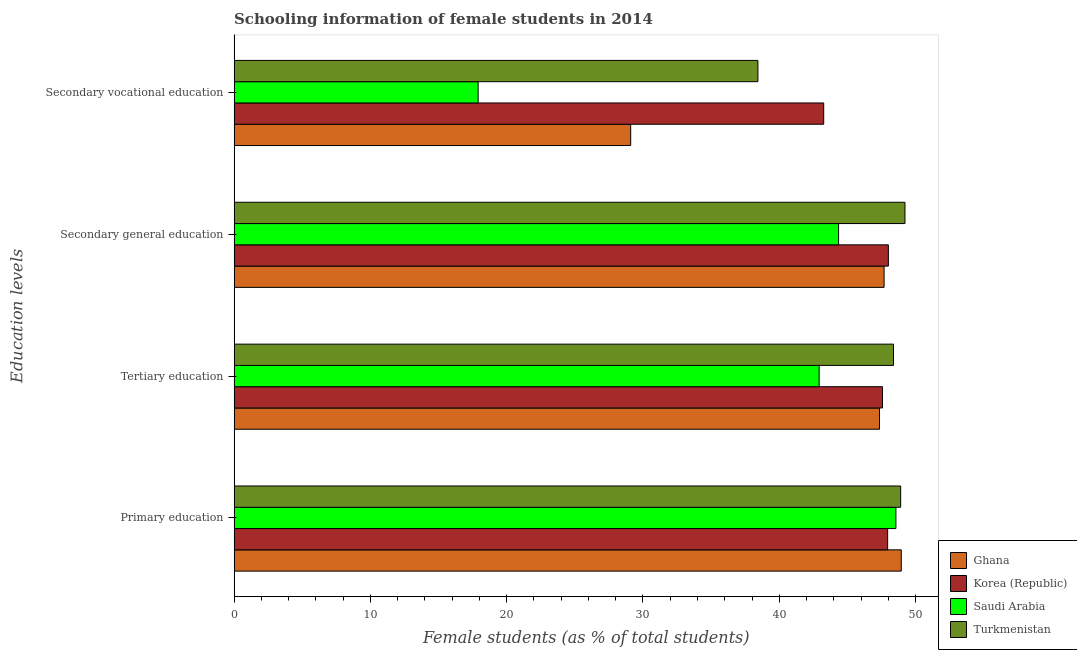Are the number of bars per tick equal to the number of legend labels?
Ensure brevity in your answer.  Yes. Are the number of bars on each tick of the Y-axis equal?
Provide a succinct answer. Yes. How many bars are there on the 3rd tick from the top?
Make the answer very short. 4. How many bars are there on the 2nd tick from the bottom?
Provide a succinct answer. 4. What is the label of the 3rd group of bars from the top?
Offer a terse response. Tertiary education. What is the percentage of female students in secondary education in Korea (Republic)?
Offer a very short reply. 48.01. Across all countries, what is the maximum percentage of female students in primary education?
Keep it short and to the point. 48.95. Across all countries, what is the minimum percentage of female students in secondary vocational education?
Your answer should be very brief. 17.91. In which country was the percentage of female students in tertiary education maximum?
Make the answer very short. Turkmenistan. In which country was the percentage of female students in secondary vocational education minimum?
Your answer should be compact. Saudi Arabia. What is the total percentage of female students in tertiary education in the graph?
Ensure brevity in your answer.  186.24. What is the difference between the percentage of female students in tertiary education in Turkmenistan and that in Saudi Arabia?
Give a very brief answer. 5.46. What is the difference between the percentage of female students in secondary vocational education in Korea (Republic) and the percentage of female students in primary education in Saudi Arabia?
Offer a terse response. -5.3. What is the average percentage of female students in primary education per country?
Provide a succinct answer. 48.59. What is the difference between the percentage of female students in secondary education and percentage of female students in primary education in Turkmenistan?
Your response must be concise. 0.32. What is the ratio of the percentage of female students in primary education in Ghana to that in Saudi Arabia?
Offer a very short reply. 1.01. Is the percentage of female students in secondary vocational education in Ghana less than that in Saudi Arabia?
Your answer should be very brief. No. Is the difference between the percentage of female students in tertiary education in Saudi Arabia and Turkmenistan greater than the difference between the percentage of female students in secondary vocational education in Saudi Arabia and Turkmenistan?
Your answer should be compact. Yes. What is the difference between the highest and the second highest percentage of female students in secondary vocational education?
Your answer should be very brief. 4.83. What is the difference between the highest and the lowest percentage of female students in secondary vocational education?
Your answer should be very brief. 25.36. Is it the case that in every country, the sum of the percentage of female students in tertiary education and percentage of female students in secondary vocational education is greater than the sum of percentage of female students in primary education and percentage of female students in secondary education?
Offer a terse response. Yes. Is it the case that in every country, the sum of the percentage of female students in primary education and percentage of female students in tertiary education is greater than the percentage of female students in secondary education?
Provide a short and direct response. Yes. Does the graph contain grids?
Your response must be concise. No. How many legend labels are there?
Your response must be concise. 4. How are the legend labels stacked?
Your response must be concise. Vertical. What is the title of the graph?
Offer a very short reply. Schooling information of female students in 2014. What is the label or title of the X-axis?
Make the answer very short. Female students (as % of total students). What is the label or title of the Y-axis?
Offer a very short reply. Education levels. What is the Female students (as % of total students) of Ghana in Primary education?
Offer a terse response. 48.95. What is the Female students (as % of total students) in Korea (Republic) in Primary education?
Ensure brevity in your answer.  47.95. What is the Female students (as % of total students) in Saudi Arabia in Primary education?
Make the answer very short. 48.56. What is the Female students (as % of total students) in Turkmenistan in Primary education?
Offer a very short reply. 48.91. What is the Female students (as % of total students) of Ghana in Tertiary education?
Your answer should be very brief. 47.35. What is the Female students (as % of total students) in Korea (Republic) in Tertiary education?
Your answer should be very brief. 47.58. What is the Female students (as % of total students) of Saudi Arabia in Tertiary education?
Your response must be concise. 42.92. What is the Female students (as % of total students) in Turkmenistan in Tertiary education?
Offer a very short reply. 48.38. What is the Female students (as % of total students) in Ghana in Secondary general education?
Provide a short and direct response. 47.69. What is the Female students (as % of total students) of Korea (Republic) in Secondary general education?
Ensure brevity in your answer.  48.01. What is the Female students (as % of total students) in Saudi Arabia in Secondary general education?
Make the answer very short. 44.35. What is the Female students (as % of total students) in Turkmenistan in Secondary general education?
Your answer should be very brief. 49.22. What is the Female students (as % of total students) in Ghana in Secondary vocational education?
Provide a succinct answer. 29.1. What is the Female students (as % of total students) of Korea (Republic) in Secondary vocational education?
Provide a succinct answer. 43.26. What is the Female students (as % of total students) in Saudi Arabia in Secondary vocational education?
Your response must be concise. 17.91. What is the Female students (as % of total students) of Turkmenistan in Secondary vocational education?
Provide a short and direct response. 38.43. Across all Education levels, what is the maximum Female students (as % of total students) of Ghana?
Give a very brief answer. 48.95. Across all Education levels, what is the maximum Female students (as % of total students) of Korea (Republic)?
Ensure brevity in your answer.  48.01. Across all Education levels, what is the maximum Female students (as % of total students) of Saudi Arabia?
Provide a short and direct response. 48.56. Across all Education levels, what is the maximum Female students (as % of total students) in Turkmenistan?
Offer a terse response. 49.22. Across all Education levels, what is the minimum Female students (as % of total students) of Ghana?
Your answer should be very brief. 29.1. Across all Education levels, what is the minimum Female students (as % of total students) of Korea (Republic)?
Ensure brevity in your answer.  43.26. Across all Education levels, what is the minimum Female students (as % of total students) of Saudi Arabia?
Keep it short and to the point. 17.91. Across all Education levels, what is the minimum Female students (as % of total students) in Turkmenistan?
Your answer should be very brief. 38.43. What is the total Female students (as % of total students) in Ghana in the graph?
Your answer should be very brief. 173.1. What is the total Female students (as % of total students) in Korea (Republic) in the graph?
Your answer should be very brief. 186.79. What is the total Female students (as % of total students) in Saudi Arabia in the graph?
Your response must be concise. 153.74. What is the total Female students (as % of total students) of Turkmenistan in the graph?
Your answer should be very brief. 184.94. What is the difference between the Female students (as % of total students) of Ghana in Primary education and that in Tertiary education?
Provide a short and direct response. 1.6. What is the difference between the Female students (as % of total students) of Korea (Republic) in Primary education and that in Tertiary education?
Offer a very short reply. 0.38. What is the difference between the Female students (as % of total students) of Saudi Arabia in Primary education and that in Tertiary education?
Keep it short and to the point. 5.63. What is the difference between the Female students (as % of total students) in Turkmenistan in Primary education and that in Tertiary education?
Offer a terse response. 0.53. What is the difference between the Female students (as % of total students) of Ghana in Primary education and that in Secondary general education?
Your answer should be compact. 1.26. What is the difference between the Female students (as % of total students) of Korea (Republic) in Primary education and that in Secondary general education?
Ensure brevity in your answer.  -0.05. What is the difference between the Female students (as % of total students) of Saudi Arabia in Primary education and that in Secondary general education?
Make the answer very short. 4.21. What is the difference between the Female students (as % of total students) of Turkmenistan in Primary education and that in Secondary general education?
Provide a short and direct response. -0.32. What is the difference between the Female students (as % of total students) in Ghana in Primary education and that in Secondary vocational education?
Give a very brief answer. 19.85. What is the difference between the Female students (as % of total students) in Korea (Republic) in Primary education and that in Secondary vocational education?
Keep it short and to the point. 4.69. What is the difference between the Female students (as % of total students) of Saudi Arabia in Primary education and that in Secondary vocational education?
Offer a terse response. 30.65. What is the difference between the Female students (as % of total students) of Turkmenistan in Primary education and that in Secondary vocational education?
Your answer should be compact. 10.47. What is the difference between the Female students (as % of total students) in Ghana in Tertiary education and that in Secondary general education?
Offer a terse response. -0.34. What is the difference between the Female students (as % of total students) of Korea (Republic) in Tertiary education and that in Secondary general education?
Your answer should be very brief. -0.43. What is the difference between the Female students (as % of total students) of Saudi Arabia in Tertiary education and that in Secondary general education?
Provide a succinct answer. -1.43. What is the difference between the Female students (as % of total students) of Turkmenistan in Tertiary education and that in Secondary general education?
Your answer should be very brief. -0.84. What is the difference between the Female students (as % of total students) of Ghana in Tertiary education and that in Secondary vocational education?
Your answer should be very brief. 18.26. What is the difference between the Female students (as % of total students) of Korea (Republic) in Tertiary education and that in Secondary vocational education?
Your answer should be very brief. 4.31. What is the difference between the Female students (as % of total students) in Saudi Arabia in Tertiary education and that in Secondary vocational education?
Your answer should be compact. 25.02. What is the difference between the Female students (as % of total students) of Turkmenistan in Tertiary education and that in Secondary vocational education?
Provide a short and direct response. 9.95. What is the difference between the Female students (as % of total students) of Ghana in Secondary general education and that in Secondary vocational education?
Your response must be concise. 18.59. What is the difference between the Female students (as % of total students) in Korea (Republic) in Secondary general education and that in Secondary vocational education?
Give a very brief answer. 4.74. What is the difference between the Female students (as % of total students) in Saudi Arabia in Secondary general education and that in Secondary vocational education?
Your answer should be compact. 26.45. What is the difference between the Female students (as % of total students) of Turkmenistan in Secondary general education and that in Secondary vocational education?
Your answer should be very brief. 10.79. What is the difference between the Female students (as % of total students) in Ghana in Primary education and the Female students (as % of total students) in Korea (Republic) in Tertiary education?
Your answer should be compact. 1.38. What is the difference between the Female students (as % of total students) of Ghana in Primary education and the Female students (as % of total students) of Saudi Arabia in Tertiary education?
Keep it short and to the point. 6.03. What is the difference between the Female students (as % of total students) in Ghana in Primary education and the Female students (as % of total students) in Turkmenistan in Tertiary education?
Provide a short and direct response. 0.57. What is the difference between the Female students (as % of total students) in Korea (Republic) in Primary education and the Female students (as % of total students) in Saudi Arabia in Tertiary education?
Offer a terse response. 5.03. What is the difference between the Female students (as % of total students) of Korea (Republic) in Primary education and the Female students (as % of total students) of Turkmenistan in Tertiary education?
Ensure brevity in your answer.  -0.43. What is the difference between the Female students (as % of total students) of Saudi Arabia in Primary education and the Female students (as % of total students) of Turkmenistan in Tertiary education?
Your response must be concise. 0.18. What is the difference between the Female students (as % of total students) in Ghana in Primary education and the Female students (as % of total students) in Korea (Republic) in Secondary general education?
Give a very brief answer. 0.95. What is the difference between the Female students (as % of total students) of Ghana in Primary education and the Female students (as % of total students) of Saudi Arabia in Secondary general education?
Your answer should be compact. 4.6. What is the difference between the Female students (as % of total students) of Ghana in Primary education and the Female students (as % of total students) of Turkmenistan in Secondary general education?
Provide a short and direct response. -0.27. What is the difference between the Female students (as % of total students) of Korea (Republic) in Primary education and the Female students (as % of total students) of Saudi Arabia in Secondary general education?
Your answer should be very brief. 3.6. What is the difference between the Female students (as % of total students) in Korea (Republic) in Primary education and the Female students (as % of total students) in Turkmenistan in Secondary general education?
Offer a terse response. -1.27. What is the difference between the Female students (as % of total students) in Saudi Arabia in Primary education and the Female students (as % of total students) in Turkmenistan in Secondary general education?
Your answer should be compact. -0.66. What is the difference between the Female students (as % of total students) in Ghana in Primary education and the Female students (as % of total students) in Korea (Republic) in Secondary vocational education?
Offer a very short reply. 5.69. What is the difference between the Female students (as % of total students) in Ghana in Primary education and the Female students (as % of total students) in Saudi Arabia in Secondary vocational education?
Your response must be concise. 31.05. What is the difference between the Female students (as % of total students) in Ghana in Primary education and the Female students (as % of total students) in Turkmenistan in Secondary vocational education?
Provide a short and direct response. 10.52. What is the difference between the Female students (as % of total students) of Korea (Republic) in Primary education and the Female students (as % of total students) of Saudi Arabia in Secondary vocational education?
Your response must be concise. 30.05. What is the difference between the Female students (as % of total students) of Korea (Republic) in Primary education and the Female students (as % of total students) of Turkmenistan in Secondary vocational education?
Keep it short and to the point. 9.52. What is the difference between the Female students (as % of total students) in Saudi Arabia in Primary education and the Female students (as % of total students) in Turkmenistan in Secondary vocational education?
Keep it short and to the point. 10.13. What is the difference between the Female students (as % of total students) of Ghana in Tertiary education and the Female students (as % of total students) of Korea (Republic) in Secondary general education?
Keep it short and to the point. -0.65. What is the difference between the Female students (as % of total students) of Ghana in Tertiary education and the Female students (as % of total students) of Saudi Arabia in Secondary general education?
Ensure brevity in your answer.  3. What is the difference between the Female students (as % of total students) in Ghana in Tertiary education and the Female students (as % of total students) in Turkmenistan in Secondary general education?
Your answer should be very brief. -1.87. What is the difference between the Female students (as % of total students) of Korea (Republic) in Tertiary education and the Female students (as % of total students) of Saudi Arabia in Secondary general education?
Provide a succinct answer. 3.22. What is the difference between the Female students (as % of total students) of Korea (Republic) in Tertiary education and the Female students (as % of total students) of Turkmenistan in Secondary general education?
Give a very brief answer. -1.65. What is the difference between the Female students (as % of total students) in Saudi Arabia in Tertiary education and the Female students (as % of total students) in Turkmenistan in Secondary general education?
Ensure brevity in your answer.  -6.3. What is the difference between the Female students (as % of total students) of Ghana in Tertiary education and the Female students (as % of total students) of Korea (Republic) in Secondary vocational education?
Offer a very short reply. 4.09. What is the difference between the Female students (as % of total students) of Ghana in Tertiary education and the Female students (as % of total students) of Saudi Arabia in Secondary vocational education?
Make the answer very short. 29.45. What is the difference between the Female students (as % of total students) of Ghana in Tertiary education and the Female students (as % of total students) of Turkmenistan in Secondary vocational education?
Keep it short and to the point. 8.92. What is the difference between the Female students (as % of total students) of Korea (Republic) in Tertiary education and the Female students (as % of total students) of Saudi Arabia in Secondary vocational education?
Provide a succinct answer. 29.67. What is the difference between the Female students (as % of total students) in Korea (Republic) in Tertiary education and the Female students (as % of total students) in Turkmenistan in Secondary vocational education?
Provide a succinct answer. 9.14. What is the difference between the Female students (as % of total students) in Saudi Arabia in Tertiary education and the Female students (as % of total students) in Turkmenistan in Secondary vocational education?
Your response must be concise. 4.49. What is the difference between the Female students (as % of total students) in Ghana in Secondary general education and the Female students (as % of total students) in Korea (Republic) in Secondary vocational education?
Give a very brief answer. 4.43. What is the difference between the Female students (as % of total students) in Ghana in Secondary general education and the Female students (as % of total students) in Saudi Arabia in Secondary vocational education?
Keep it short and to the point. 29.79. What is the difference between the Female students (as % of total students) in Ghana in Secondary general education and the Female students (as % of total students) in Turkmenistan in Secondary vocational education?
Offer a terse response. 9.26. What is the difference between the Female students (as % of total students) in Korea (Republic) in Secondary general education and the Female students (as % of total students) in Saudi Arabia in Secondary vocational education?
Ensure brevity in your answer.  30.1. What is the difference between the Female students (as % of total students) in Korea (Republic) in Secondary general education and the Female students (as % of total students) in Turkmenistan in Secondary vocational education?
Your answer should be very brief. 9.57. What is the difference between the Female students (as % of total students) of Saudi Arabia in Secondary general education and the Female students (as % of total students) of Turkmenistan in Secondary vocational education?
Your answer should be very brief. 5.92. What is the average Female students (as % of total students) in Ghana per Education levels?
Give a very brief answer. 43.27. What is the average Female students (as % of total students) of Korea (Republic) per Education levels?
Provide a succinct answer. 46.7. What is the average Female students (as % of total students) of Saudi Arabia per Education levels?
Provide a short and direct response. 38.44. What is the average Female students (as % of total students) of Turkmenistan per Education levels?
Provide a succinct answer. 46.24. What is the difference between the Female students (as % of total students) of Ghana and Female students (as % of total students) of Korea (Republic) in Primary education?
Your response must be concise. 1. What is the difference between the Female students (as % of total students) of Ghana and Female students (as % of total students) of Saudi Arabia in Primary education?
Keep it short and to the point. 0.39. What is the difference between the Female students (as % of total students) of Ghana and Female students (as % of total students) of Turkmenistan in Primary education?
Offer a terse response. 0.04. What is the difference between the Female students (as % of total students) in Korea (Republic) and Female students (as % of total students) in Saudi Arabia in Primary education?
Ensure brevity in your answer.  -0.61. What is the difference between the Female students (as % of total students) of Korea (Republic) and Female students (as % of total students) of Turkmenistan in Primary education?
Offer a terse response. -0.95. What is the difference between the Female students (as % of total students) in Saudi Arabia and Female students (as % of total students) in Turkmenistan in Primary education?
Provide a succinct answer. -0.35. What is the difference between the Female students (as % of total students) of Ghana and Female students (as % of total students) of Korea (Republic) in Tertiary education?
Ensure brevity in your answer.  -0.22. What is the difference between the Female students (as % of total students) of Ghana and Female students (as % of total students) of Saudi Arabia in Tertiary education?
Ensure brevity in your answer.  4.43. What is the difference between the Female students (as % of total students) in Ghana and Female students (as % of total students) in Turkmenistan in Tertiary education?
Your answer should be very brief. -1.03. What is the difference between the Female students (as % of total students) in Korea (Republic) and Female students (as % of total students) in Saudi Arabia in Tertiary education?
Offer a very short reply. 4.65. What is the difference between the Female students (as % of total students) in Korea (Republic) and Female students (as % of total students) in Turkmenistan in Tertiary education?
Your answer should be compact. -0.81. What is the difference between the Female students (as % of total students) of Saudi Arabia and Female students (as % of total students) of Turkmenistan in Tertiary education?
Offer a terse response. -5.46. What is the difference between the Female students (as % of total students) in Ghana and Female students (as % of total students) in Korea (Republic) in Secondary general education?
Offer a terse response. -0.31. What is the difference between the Female students (as % of total students) of Ghana and Female students (as % of total students) of Saudi Arabia in Secondary general education?
Offer a terse response. 3.34. What is the difference between the Female students (as % of total students) of Ghana and Female students (as % of total students) of Turkmenistan in Secondary general education?
Offer a terse response. -1.53. What is the difference between the Female students (as % of total students) in Korea (Republic) and Female students (as % of total students) in Saudi Arabia in Secondary general education?
Keep it short and to the point. 3.65. What is the difference between the Female students (as % of total students) in Korea (Republic) and Female students (as % of total students) in Turkmenistan in Secondary general education?
Make the answer very short. -1.22. What is the difference between the Female students (as % of total students) in Saudi Arabia and Female students (as % of total students) in Turkmenistan in Secondary general education?
Your answer should be compact. -4.87. What is the difference between the Female students (as % of total students) of Ghana and Female students (as % of total students) of Korea (Republic) in Secondary vocational education?
Your answer should be compact. -14.16. What is the difference between the Female students (as % of total students) of Ghana and Female students (as % of total students) of Saudi Arabia in Secondary vocational education?
Offer a very short reply. 11.19. What is the difference between the Female students (as % of total students) of Ghana and Female students (as % of total students) of Turkmenistan in Secondary vocational education?
Give a very brief answer. -9.34. What is the difference between the Female students (as % of total students) in Korea (Republic) and Female students (as % of total students) in Saudi Arabia in Secondary vocational education?
Ensure brevity in your answer.  25.36. What is the difference between the Female students (as % of total students) of Korea (Republic) and Female students (as % of total students) of Turkmenistan in Secondary vocational education?
Keep it short and to the point. 4.83. What is the difference between the Female students (as % of total students) in Saudi Arabia and Female students (as % of total students) in Turkmenistan in Secondary vocational education?
Make the answer very short. -20.53. What is the ratio of the Female students (as % of total students) of Ghana in Primary education to that in Tertiary education?
Keep it short and to the point. 1.03. What is the ratio of the Female students (as % of total students) of Korea (Republic) in Primary education to that in Tertiary education?
Provide a short and direct response. 1.01. What is the ratio of the Female students (as % of total students) in Saudi Arabia in Primary education to that in Tertiary education?
Provide a short and direct response. 1.13. What is the ratio of the Female students (as % of total students) in Turkmenistan in Primary education to that in Tertiary education?
Give a very brief answer. 1.01. What is the ratio of the Female students (as % of total students) of Ghana in Primary education to that in Secondary general education?
Make the answer very short. 1.03. What is the ratio of the Female students (as % of total students) of Korea (Republic) in Primary education to that in Secondary general education?
Provide a short and direct response. 1. What is the ratio of the Female students (as % of total students) of Saudi Arabia in Primary education to that in Secondary general education?
Give a very brief answer. 1.09. What is the ratio of the Female students (as % of total students) in Turkmenistan in Primary education to that in Secondary general education?
Ensure brevity in your answer.  0.99. What is the ratio of the Female students (as % of total students) in Ghana in Primary education to that in Secondary vocational education?
Provide a succinct answer. 1.68. What is the ratio of the Female students (as % of total students) in Korea (Republic) in Primary education to that in Secondary vocational education?
Ensure brevity in your answer.  1.11. What is the ratio of the Female students (as % of total students) in Saudi Arabia in Primary education to that in Secondary vocational education?
Offer a very short reply. 2.71. What is the ratio of the Female students (as % of total students) of Turkmenistan in Primary education to that in Secondary vocational education?
Provide a short and direct response. 1.27. What is the ratio of the Female students (as % of total students) of Korea (Republic) in Tertiary education to that in Secondary general education?
Make the answer very short. 0.99. What is the ratio of the Female students (as % of total students) of Saudi Arabia in Tertiary education to that in Secondary general education?
Offer a very short reply. 0.97. What is the ratio of the Female students (as % of total students) in Turkmenistan in Tertiary education to that in Secondary general education?
Offer a terse response. 0.98. What is the ratio of the Female students (as % of total students) in Ghana in Tertiary education to that in Secondary vocational education?
Give a very brief answer. 1.63. What is the ratio of the Female students (as % of total students) in Korea (Republic) in Tertiary education to that in Secondary vocational education?
Your answer should be compact. 1.1. What is the ratio of the Female students (as % of total students) of Saudi Arabia in Tertiary education to that in Secondary vocational education?
Offer a very short reply. 2.4. What is the ratio of the Female students (as % of total students) in Turkmenistan in Tertiary education to that in Secondary vocational education?
Give a very brief answer. 1.26. What is the ratio of the Female students (as % of total students) in Ghana in Secondary general education to that in Secondary vocational education?
Ensure brevity in your answer.  1.64. What is the ratio of the Female students (as % of total students) of Korea (Republic) in Secondary general education to that in Secondary vocational education?
Make the answer very short. 1.11. What is the ratio of the Female students (as % of total students) in Saudi Arabia in Secondary general education to that in Secondary vocational education?
Your answer should be compact. 2.48. What is the ratio of the Female students (as % of total students) in Turkmenistan in Secondary general education to that in Secondary vocational education?
Give a very brief answer. 1.28. What is the difference between the highest and the second highest Female students (as % of total students) of Ghana?
Your answer should be compact. 1.26. What is the difference between the highest and the second highest Female students (as % of total students) of Korea (Republic)?
Your answer should be very brief. 0.05. What is the difference between the highest and the second highest Female students (as % of total students) in Saudi Arabia?
Your response must be concise. 4.21. What is the difference between the highest and the second highest Female students (as % of total students) of Turkmenistan?
Ensure brevity in your answer.  0.32. What is the difference between the highest and the lowest Female students (as % of total students) in Ghana?
Offer a terse response. 19.85. What is the difference between the highest and the lowest Female students (as % of total students) in Korea (Republic)?
Your answer should be compact. 4.74. What is the difference between the highest and the lowest Female students (as % of total students) of Saudi Arabia?
Provide a short and direct response. 30.65. What is the difference between the highest and the lowest Female students (as % of total students) of Turkmenistan?
Offer a terse response. 10.79. 